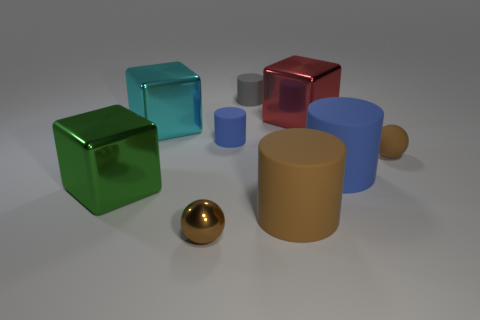What is the color of the thing that is on the right side of the gray matte cylinder and behind the cyan object?
Your response must be concise. Red. What number of shiny blocks are the same color as the tiny shiny object?
Your response must be concise. 0. What number of cylinders are either cyan shiny things or small things?
Make the answer very short. 2. The sphere that is the same size as the brown shiny object is what color?
Provide a succinct answer. Brown. Are there any small blue rubber cylinders that are in front of the large matte object that is behind the shiny thing left of the large cyan shiny object?
Ensure brevity in your answer.  No. What size is the green thing?
Your answer should be compact. Large. How many things are red blocks or gray matte objects?
Provide a short and direct response. 2. There is a ball that is the same material as the red cube; what color is it?
Your answer should be very brief. Brown. Do the blue thing on the left side of the big blue cylinder and the red metallic object have the same shape?
Your answer should be compact. No. What number of things are small objects that are on the left side of the small gray matte cylinder or blocks behind the green block?
Provide a short and direct response. 4. 